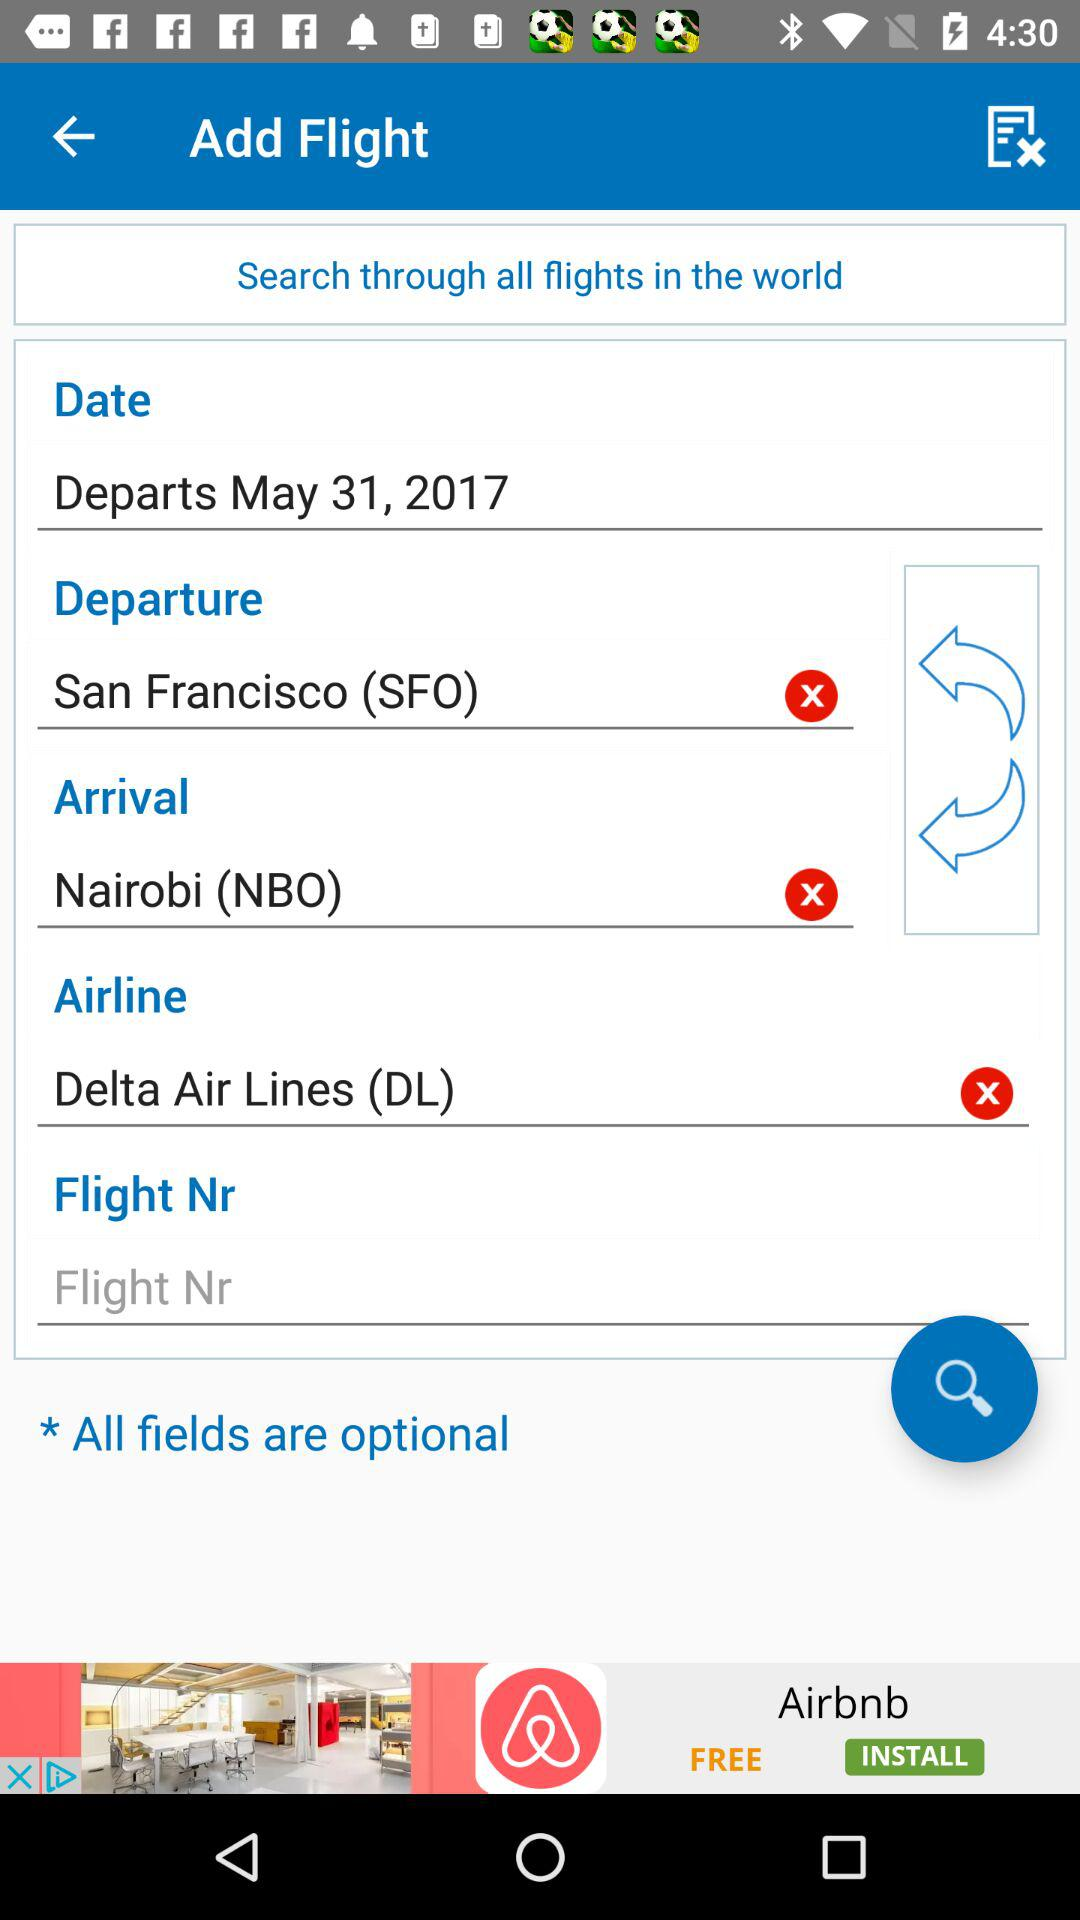Where will the flight depart from? The flight will depart from San Francisco (SFO). 